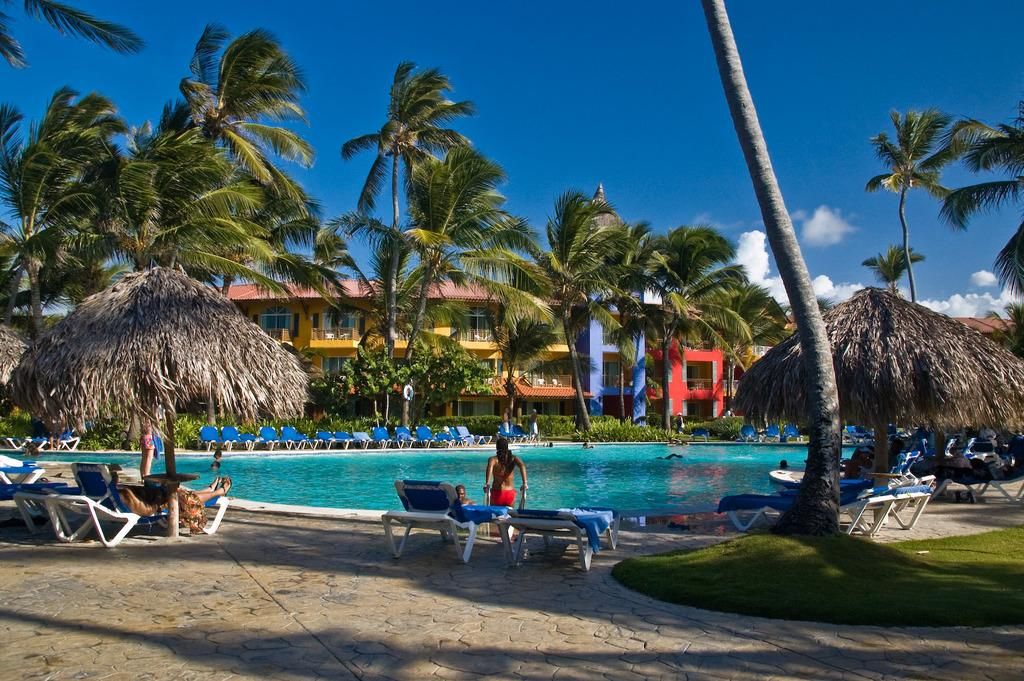What type of furniture can be seen in the image? There are chairs in the image. What are the people in the image doing? The people are on the ground in the image. What natural element is visible in the image? There is water visible in the image. What type of vehicle is present in the image? There is a boat in the image. What type of vegetation is present in the image? There are trees and grass in the image. What structures can be seen in the background of the image? There are buildings in the background of the image. What is visible in the sky in the image? The sky is visible in the background of the image, and there are clouds in the sky. What type of suit is the cub wearing in the image? There is no cub or suit present in the image. What route are the people taking in the image? The image does not show any specific route or direction the people are taking. 